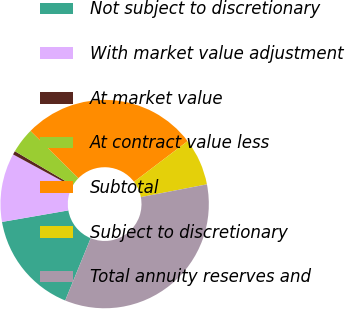<chart> <loc_0><loc_0><loc_500><loc_500><pie_chart><fcel>Not subject to discretionary<fcel>With market value adjustment<fcel>At market value<fcel>At contract value less<fcel>Subtotal<fcel>Subject to discretionary<fcel>Total annuity reserves and<nl><fcel>16.08%<fcel>10.65%<fcel>0.56%<fcel>3.92%<fcel>27.28%<fcel>7.29%<fcel>34.21%<nl></chart> 